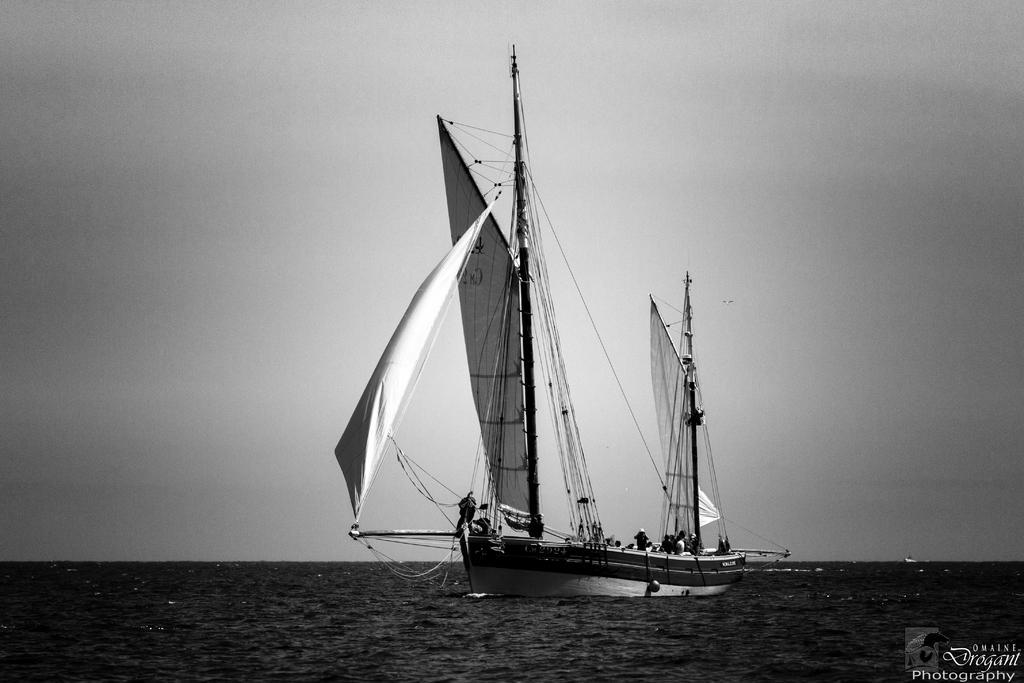Describe this image in one or two sentences. This is a black and white pic. Here we can see few persons riding in a boat on the water and we can also see clothes,ropes,poles and this is a sky. 